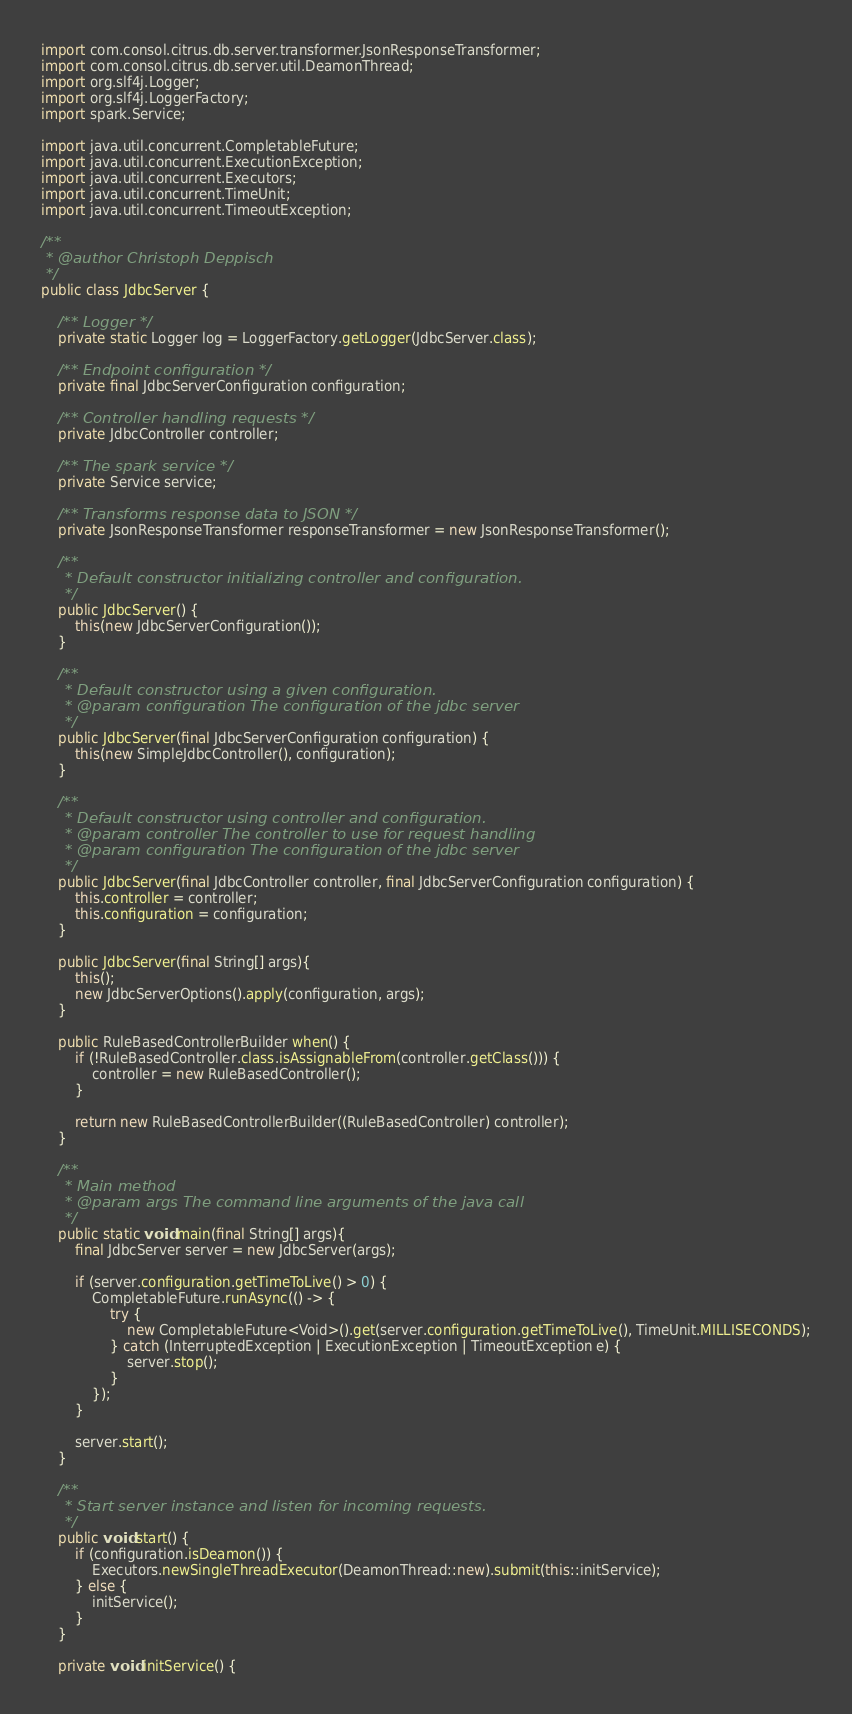Convert code to text. <code><loc_0><loc_0><loc_500><loc_500><_Java_>import com.consol.citrus.db.server.transformer.JsonResponseTransformer;
import com.consol.citrus.db.server.util.DeamonThread;
import org.slf4j.Logger;
import org.slf4j.LoggerFactory;
import spark.Service;

import java.util.concurrent.CompletableFuture;
import java.util.concurrent.ExecutionException;
import java.util.concurrent.Executors;
import java.util.concurrent.TimeUnit;
import java.util.concurrent.TimeoutException;

/**
 * @author Christoph Deppisch
 */
public class JdbcServer {

    /** Logger */
    private static Logger log = LoggerFactory.getLogger(JdbcServer.class);

    /** Endpoint configuration */
    private final JdbcServerConfiguration configuration;

    /** Controller handling requests */
    private JdbcController controller;

    /** The spark service */
    private Service service;

    /** Transforms response data to JSON */
    private JsonResponseTransformer responseTransformer = new JsonResponseTransformer();

    /**
     * Default constructor initializing controller and configuration.
     */
    public JdbcServer() {
        this(new JdbcServerConfiguration());
    }

    /**
     * Default constructor using a given configuration.
     * @param configuration The configuration of the jdbc server
     */
    public JdbcServer(final JdbcServerConfiguration configuration) {
        this(new SimpleJdbcController(), configuration);
    }

    /**
     * Default constructor using controller and configuration.
     * @param controller The controller to use for request handling
     * @param configuration The configuration of the jdbc server
     */
    public JdbcServer(final JdbcController controller, final JdbcServerConfiguration configuration) {
        this.controller = controller;
        this.configuration = configuration;
    }

    public JdbcServer(final String[] args){
        this();
        new JdbcServerOptions().apply(configuration, args);
    }

    public RuleBasedControllerBuilder when() {
        if (!RuleBasedController.class.isAssignableFrom(controller.getClass())) {
            controller = new RuleBasedController();
        }

        return new RuleBasedControllerBuilder((RuleBasedController) controller);
    }

    /**
     * Main method
     * @param args The command line arguments of the java call
     */
    public static void main(final String[] args){
        final JdbcServer server = new JdbcServer(args);

        if (server.configuration.getTimeToLive() > 0) {
            CompletableFuture.runAsync(() -> {
                try {
                    new CompletableFuture<Void>().get(server.configuration.getTimeToLive(), TimeUnit.MILLISECONDS);
                } catch (InterruptedException | ExecutionException | TimeoutException e) {
                    server.stop();
                }
            });
        }

        server.start();
    }

    /**
     * Start server instance and listen for incoming requests.
     */
    public void start() {
        if (configuration.isDeamon()) {
            Executors.newSingleThreadExecutor(DeamonThread::new).submit(this::initService);
        } else {
            initService();
        }
    }

    private void initService() {</code> 